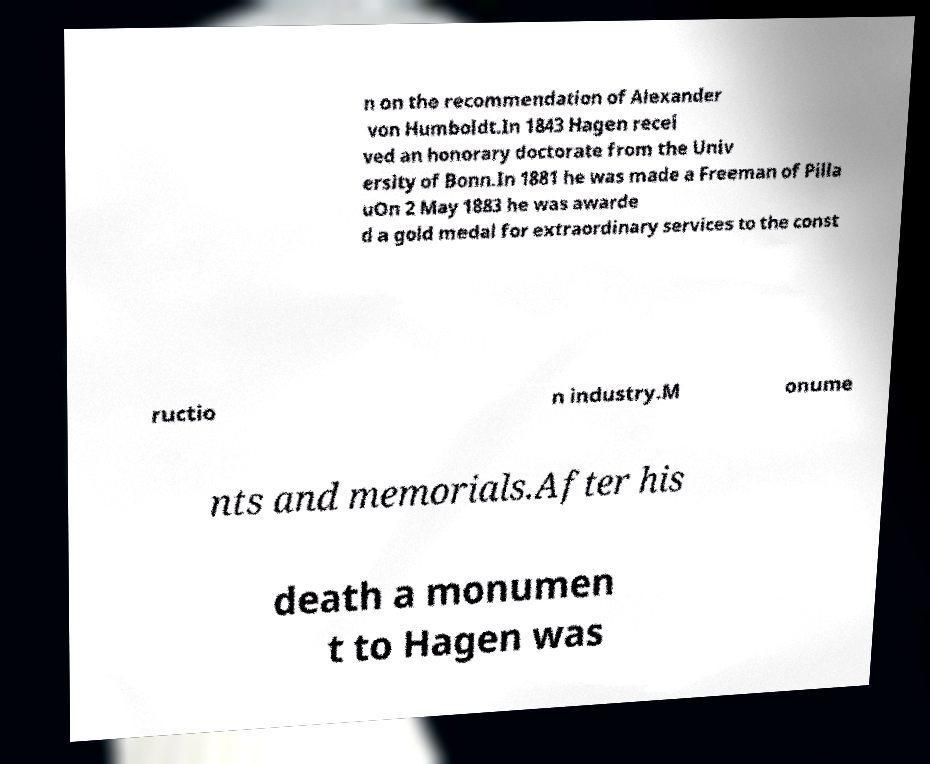What messages or text are displayed in this image? I need them in a readable, typed format. n on the recommendation of Alexander von Humboldt.In 1843 Hagen recei ved an honorary doctorate from the Univ ersity of Bonn.In 1881 he was made a Freeman of Pilla uOn 2 May 1883 he was awarde d a gold medal for extraordinary services to the const ructio n industry.M onume nts and memorials.After his death a monumen t to Hagen was 